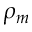<formula> <loc_0><loc_0><loc_500><loc_500>\rho _ { m }</formula> 